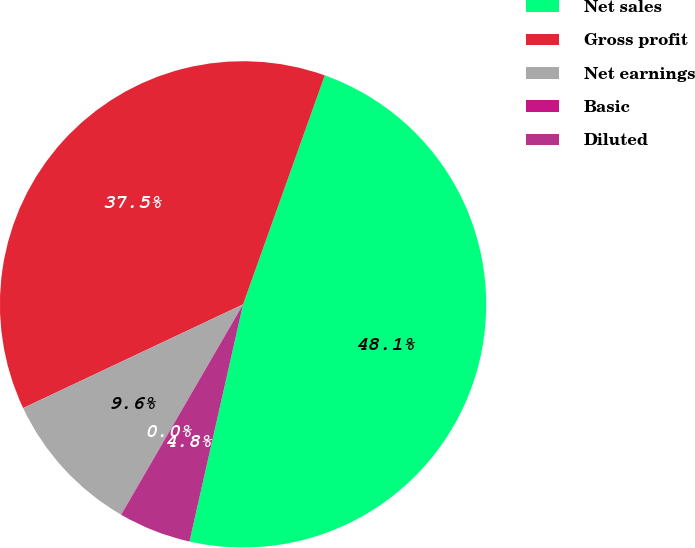Convert chart. <chart><loc_0><loc_0><loc_500><loc_500><pie_chart><fcel>Net sales<fcel>Gross profit<fcel>Net earnings<fcel>Basic<fcel>Diluted<nl><fcel>48.08%<fcel>37.47%<fcel>9.62%<fcel>0.01%<fcel>4.82%<nl></chart> 